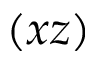<formula> <loc_0><loc_0><loc_500><loc_500>( x z )</formula> 